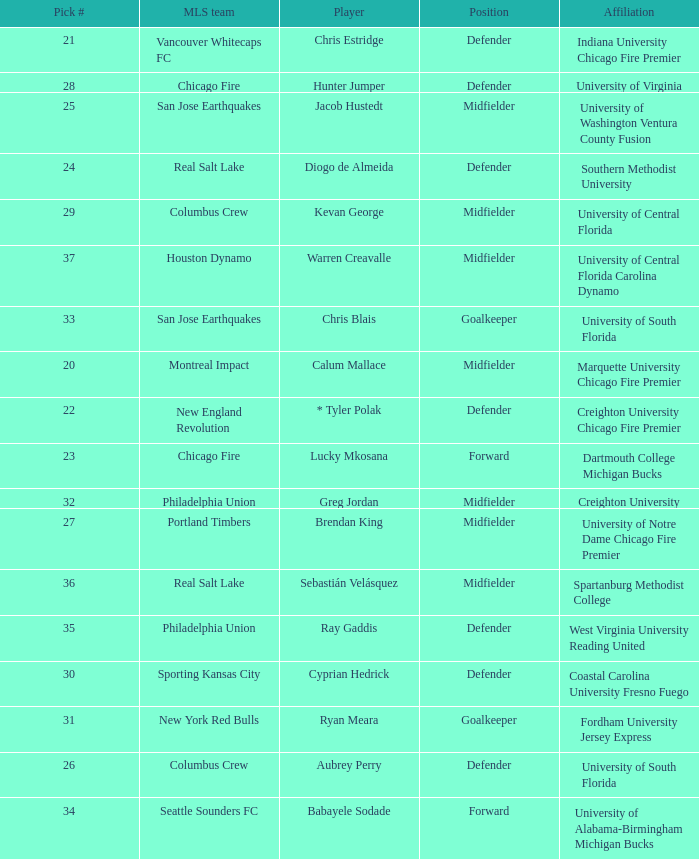What MLS team picked Babayele Sodade? Seattle Sounders FC. 